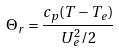<formula> <loc_0><loc_0><loc_500><loc_500>\Theta _ { r } = \frac { c _ { p } ( T - T _ { e } ) } { U _ { e } ^ { 2 } / 2 }</formula> 